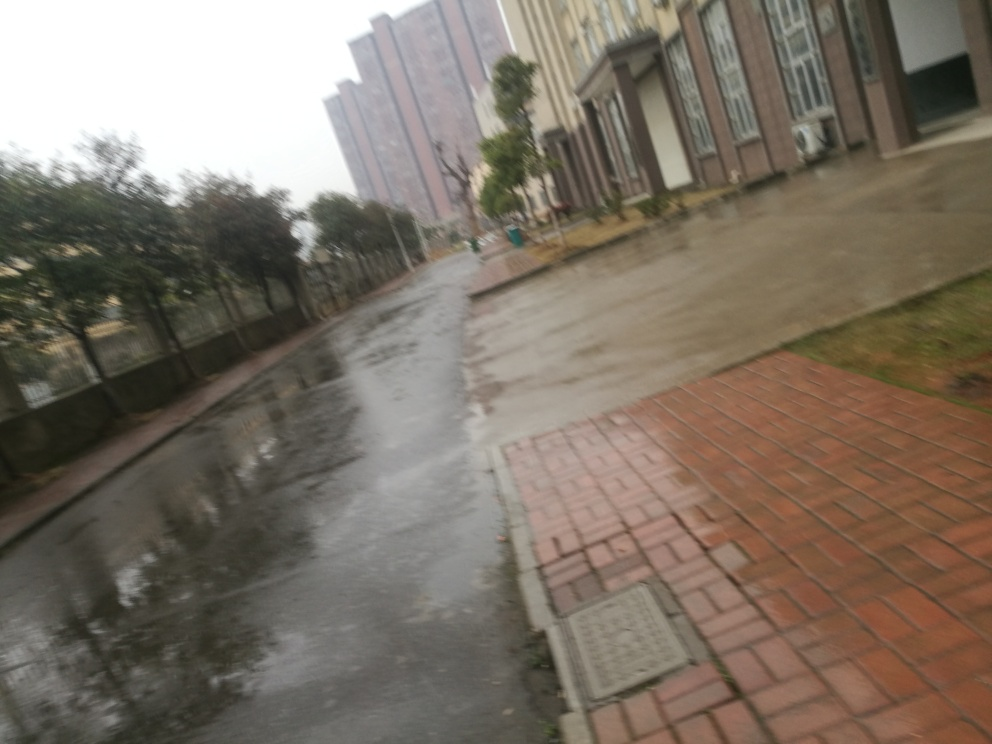What elements indicate that the weather might have been rainy when this photo was taken? The presence of puddles on the ground and the overall wet surfaces are clear indicators that it has recently rained. The overcast sky and the lack of shadows also suggest that the photo was taken on a cloudy or rainy day. 